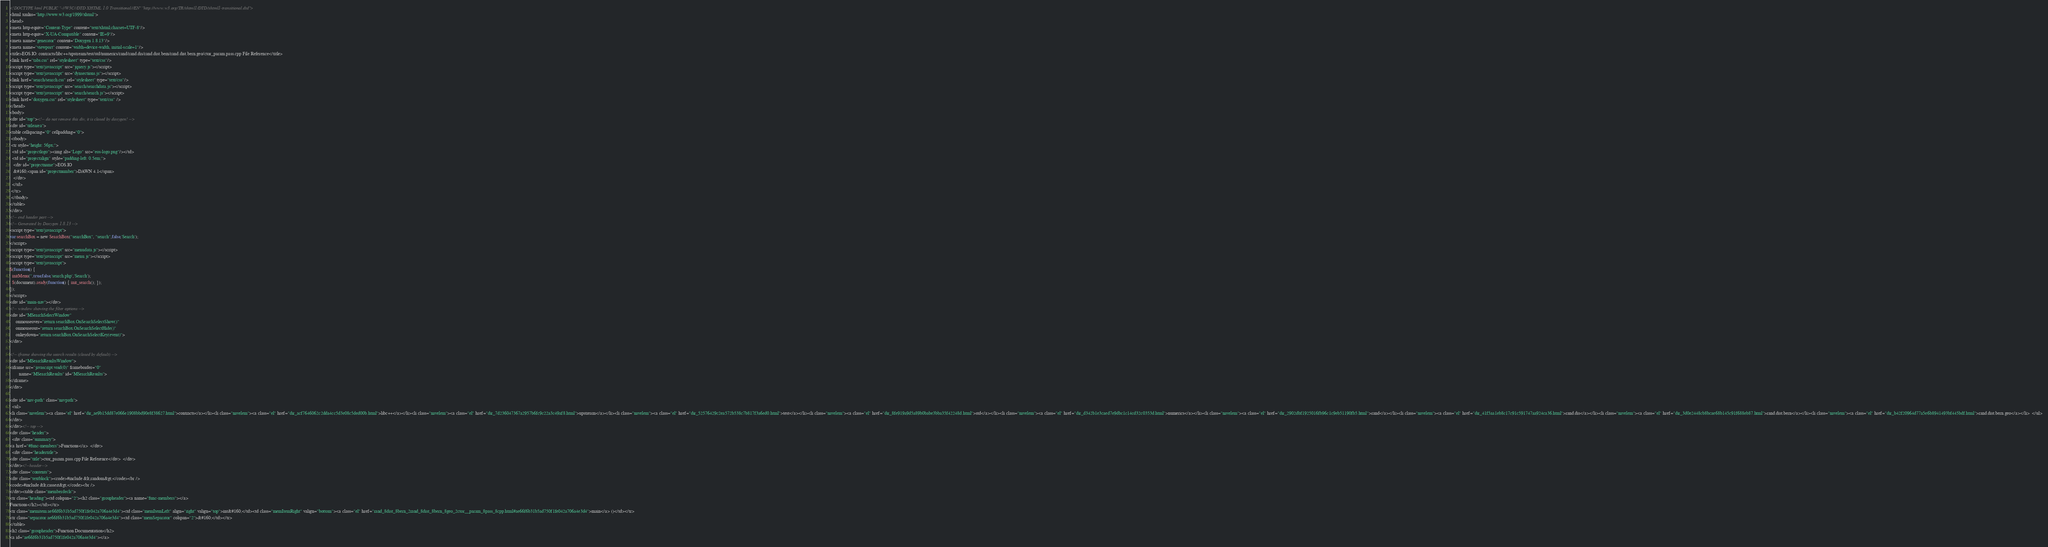<code> <loc_0><loc_0><loc_500><loc_500><_HTML_><!DOCTYPE html PUBLIC "-//W3C//DTD XHTML 1.0 Transitional//EN" "http://www.w3.org/TR/xhtml1/DTD/xhtml1-transitional.dtd">
<html xmlns="http://www.w3.org/1999/xhtml">
<head>
<meta http-equiv="Content-Type" content="text/xhtml;charset=UTF-8"/>
<meta http-equiv="X-UA-Compatible" content="IE=9"/>
<meta name="generator" content="Doxygen 1.8.13"/>
<meta name="viewport" content="width=device-width, initial-scale=1"/>
<title>EOS.IO: contracts/libc++/upstream/test/std/numerics/rand/rand.dis/rand.dist.bern/rand.dist.bern.geo/ctor_param.pass.cpp File Reference</title>
<link href="tabs.css" rel="stylesheet" type="text/css"/>
<script type="text/javascript" src="jquery.js"></script>
<script type="text/javascript" src="dynsections.js"></script>
<link href="search/search.css" rel="stylesheet" type="text/css"/>
<script type="text/javascript" src="search/searchdata.js"></script>
<script type="text/javascript" src="search/search.js"></script>
<link href="doxygen.css" rel="stylesheet" type="text/css" />
</head>
<body>
<div id="top"><!-- do not remove this div, it is closed by doxygen! -->
<div id="titlearea">
<table cellspacing="0" cellpadding="0">
 <tbody>
 <tr style="height: 56px;">
  <td id="projectlogo"><img alt="Logo" src="eos-logo.png"/></td>
  <td id="projectalign" style="padding-left: 0.5em;">
   <div id="projectname">EOS.IO
   &#160;<span id="projectnumber">DAWN 4.1</span>
   </div>
  </td>
 </tr>
 </tbody>
</table>
</div>
<!-- end header part -->
<!-- Generated by Doxygen 1.8.13 -->
<script type="text/javascript">
var searchBox = new SearchBox("searchBox", "search",false,'Search');
</script>
<script type="text/javascript" src="menudata.js"></script>
<script type="text/javascript" src="menu.js"></script>
<script type="text/javascript">
$(function() {
  initMenu('',true,false,'search.php','Search');
  $(document).ready(function() { init_search(); });
});
</script>
<div id="main-nav"></div>
<!-- window showing the filter options -->
<div id="MSearchSelectWindow"
     onmouseover="return searchBox.OnSearchSelectShow()"
     onmouseout="return searchBox.OnSearchSelectHide()"
     onkeydown="return searchBox.OnSearchSelectKey(event)">
</div>

<!-- iframe showing the search results (closed by default) -->
<div id="MSearchResultsWindow">
<iframe src="javascript:void(0)" frameborder="0" 
        name="MSearchResults" id="MSearchResults">
</iframe>
</div>

<div id="nav-path" class="navpath">
  <ul>
<li class="navelem"><a class="el" href="dir_ae9b15dd87e066e1908bbd90e8f38627.html">contracts</a></li><li class="navelem"><a class="el" href="dir_acf7646062c2dda4cc5d3e08c5ded00b.html">libc++</a></li><li class="navelem"><a class="el" href="dir_7d236047367a2957b6fc9c22a3c49af8.html">upstream</a></li><li class="navelem"><a class="el" href="dir_52576429c2ea572b538c7b817f3a6ed0.html">test</a></li><li class="navelem"><a class="el" href="dir_8fe919a9d5a89b0babe3bba35f42248d.html">std</a></li><li class="navelem"><a class="el" href="dir_d342b1e3caed7e9dbc1c14cd32c0353d.html">numerics</a></li><li class="navelem"><a class="el" href="dir_2902dbf1925016fb96c1c9eb51190fb5.html">rand</a></li><li class="navelem"><a class="el" href="dir_41f5aa1eb8c17c91c591747aa924ca36.html">rand.dis</a></li><li class="navelem"><a class="el" href="dir_3d0e2448cb8bcae68b145c91f688eb87.html">rand.dist.bern</a></li><li class="navelem"><a class="el" href="dir_b42f20964d77a5e6b8941493bf445bdf.html">rand.dist.bern.geo</a></li>  </ul>
</div>
</div><!-- top -->
<div class="header">
  <div class="summary">
<a href="#func-members">Functions</a>  </div>
  <div class="headertitle">
<div class="title">ctor_param.pass.cpp File Reference</div>  </div>
</div><!--header-->
<div class="contents">
<div class="textblock"><code>#include &lt;random&gt;</code><br />
<code>#include &lt;cassert&gt;</code><br />
</div><table class="memberdecls">
<tr class="heading"><td colspan="2"><h2 class="groupheader"><a name="func-members"></a>
Functions</h2></td></tr>
<tr class="memitem:ae66f6b31b5ad750f1fe042a706a4e3d4"><td class="memItemLeft" align="right" valign="top">int&#160;</td><td class="memItemRight" valign="bottom"><a class="el" href="rand_8dist_8bern_2rand_8dist_8bern_8geo_2ctor__param_8pass_8cpp.html#ae66f6b31b5ad750f1fe042a706a4e3d4">main</a> ()</td></tr>
<tr class="separator:ae66f6b31b5ad750f1fe042a706a4e3d4"><td class="memSeparator" colspan="2">&#160;</td></tr>
</table>
<h2 class="groupheader">Function Documentation</h2>
<a id="ae66f6b31b5ad750f1fe042a706a4e3d4"></a></code> 